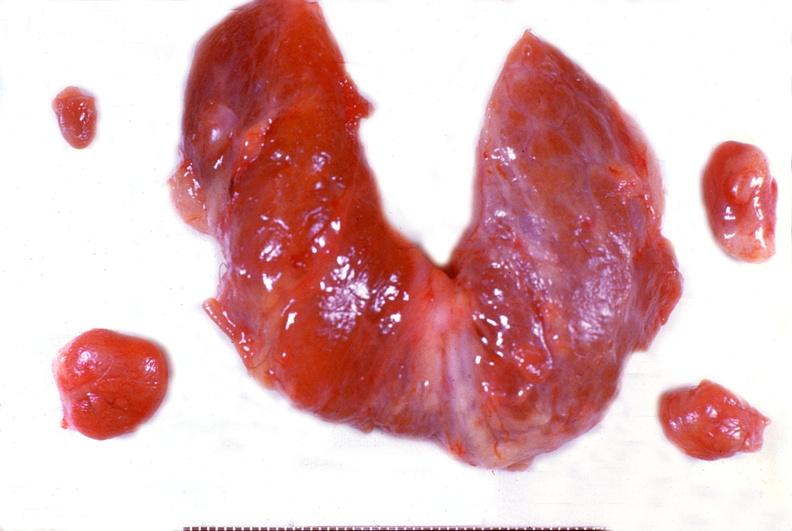does this image show parathyroid hyperplasia?
Answer the question using a single word or phrase. Yes 